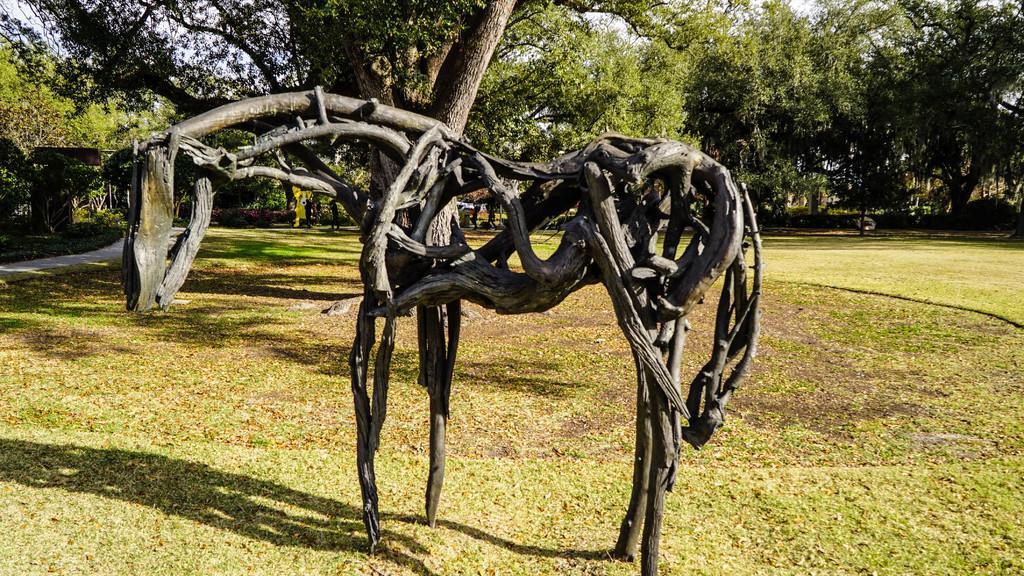In one or two sentences, can you explain what this image depicts? In this image I can see a statue of an animal which is made up of sticks. I can see the grass on the ground. In the background there are many trees. On the left side there is a road. 